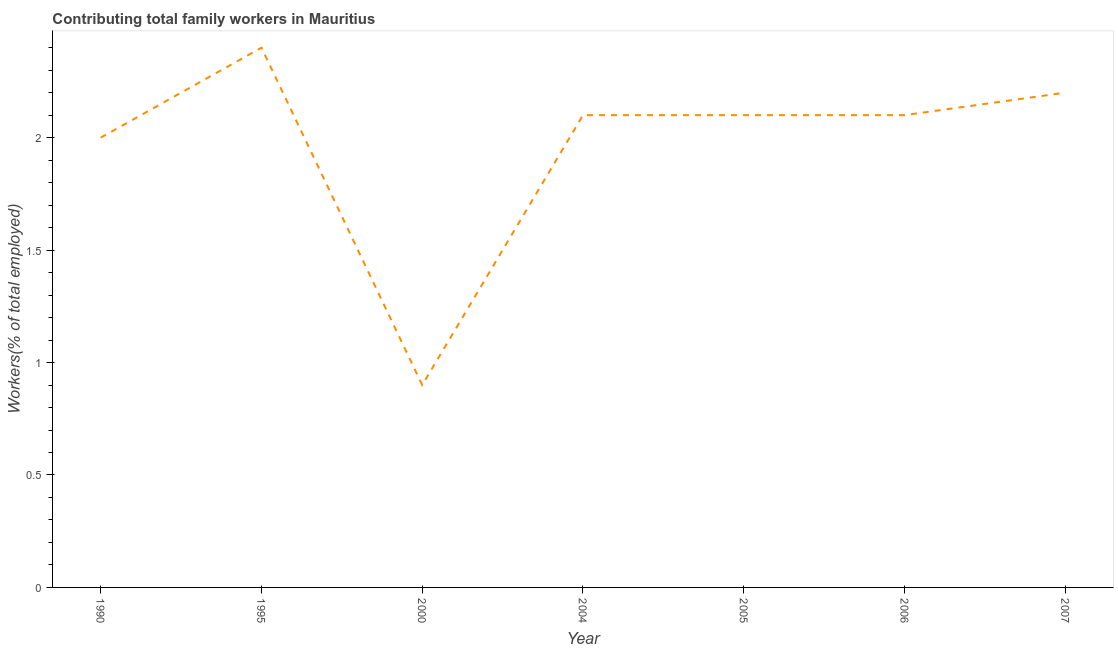What is the contributing family workers in 1995?
Give a very brief answer. 2.4. Across all years, what is the maximum contributing family workers?
Keep it short and to the point. 2.4. Across all years, what is the minimum contributing family workers?
Offer a very short reply. 0.9. What is the sum of the contributing family workers?
Ensure brevity in your answer.  13.8. What is the difference between the contributing family workers in 1995 and 2000?
Provide a succinct answer. 1.5. What is the average contributing family workers per year?
Your answer should be very brief. 1.97. What is the median contributing family workers?
Give a very brief answer. 2.1. In how many years, is the contributing family workers greater than 1.4 %?
Give a very brief answer. 6. What is the ratio of the contributing family workers in 1995 to that in 2000?
Your response must be concise. 2.67. Is the contributing family workers in 2004 less than that in 2006?
Provide a succinct answer. No. Is the difference between the contributing family workers in 1995 and 2006 greater than the difference between any two years?
Your answer should be very brief. No. What is the difference between the highest and the second highest contributing family workers?
Provide a short and direct response. 0.2. What is the difference between the highest and the lowest contributing family workers?
Your response must be concise. 1.5. Does the contributing family workers monotonically increase over the years?
Provide a succinct answer. No. How many lines are there?
Provide a short and direct response. 1. How many years are there in the graph?
Provide a succinct answer. 7. Are the values on the major ticks of Y-axis written in scientific E-notation?
Make the answer very short. No. Does the graph contain grids?
Provide a succinct answer. No. What is the title of the graph?
Make the answer very short. Contributing total family workers in Mauritius. What is the label or title of the Y-axis?
Keep it short and to the point. Workers(% of total employed). What is the Workers(% of total employed) of 1990?
Your response must be concise. 2. What is the Workers(% of total employed) of 1995?
Ensure brevity in your answer.  2.4. What is the Workers(% of total employed) in 2000?
Give a very brief answer. 0.9. What is the Workers(% of total employed) of 2004?
Give a very brief answer. 2.1. What is the Workers(% of total employed) in 2005?
Keep it short and to the point. 2.1. What is the Workers(% of total employed) of 2006?
Your answer should be compact. 2.1. What is the Workers(% of total employed) of 2007?
Ensure brevity in your answer.  2.2. What is the difference between the Workers(% of total employed) in 1990 and 2000?
Offer a very short reply. 1.1. What is the difference between the Workers(% of total employed) in 1990 and 2005?
Offer a very short reply. -0.1. What is the difference between the Workers(% of total employed) in 1990 and 2007?
Keep it short and to the point. -0.2. What is the difference between the Workers(% of total employed) in 1995 and 2004?
Offer a terse response. 0.3. What is the difference between the Workers(% of total employed) in 1995 and 2005?
Make the answer very short. 0.3. What is the difference between the Workers(% of total employed) in 1995 and 2006?
Give a very brief answer. 0.3. What is the difference between the Workers(% of total employed) in 1995 and 2007?
Keep it short and to the point. 0.2. What is the difference between the Workers(% of total employed) in 2000 and 2005?
Ensure brevity in your answer.  -1.2. What is the difference between the Workers(% of total employed) in 2000 and 2006?
Provide a short and direct response. -1.2. What is the difference between the Workers(% of total employed) in 2000 and 2007?
Offer a very short reply. -1.3. What is the difference between the Workers(% of total employed) in 2004 and 2005?
Ensure brevity in your answer.  0. What is the difference between the Workers(% of total employed) in 2004 and 2006?
Provide a short and direct response. 0. What is the difference between the Workers(% of total employed) in 2005 and 2006?
Offer a terse response. 0. What is the difference between the Workers(% of total employed) in 2006 and 2007?
Your response must be concise. -0.1. What is the ratio of the Workers(% of total employed) in 1990 to that in 1995?
Make the answer very short. 0.83. What is the ratio of the Workers(% of total employed) in 1990 to that in 2000?
Ensure brevity in your answer.  2.22. What is the ratio of the Workers(% of total employed) in 1990 to that in 2004?
Ensure brevity in your answer.  0.95. What is the ratio of the Workers(% of total employed) in 1990 to that in 2005?
Your answer should be compact. 0.95. What is the ratio of the Workers(% of total employed) in 1990 to that in 2007?
Provide a short and direct response. 0.91. What is the ratio of the Workers(% of total employed) in 1995 to that in 2000?
Make the answer very short. 2.67. What is the ratio of the Workers(% of total employed) in 1995 to that in 2004?
Your response must be concise. 1.14. What is the ratio of the Workers(% of total employed) in 1995 to that in 2005?
Provide a succinct answer. 1.14. What is the ratio of the Workers(% of total employed) in 1995 to that in 2006?
Offer a very short reply. 1.14. What is the ratio of the Workers(% of total employed) in 1995 to that in 2007?
Your response must be concise. 1.09. What is the ratio of the Workers(% of total employed) in 2000 to that in 2004?
Your answer should be compact. 0.43. What is the ratio of the Workers(% of total employed) in 2000 to that in 2005?
Make the answer very short. 0.43. What is the ratio of the Workers(% of total employed) in 2000 to that in 2006?
Provide a succinct answer. 0.43. What is the ratio of the Workers(% of total employed) in 2000 to that in 2007?
Offer a very short reply. 0.41. What is the ratio of the Workers(% of total employed) in 2004 to that in 2006?
Keep it short and to the point. 1. What is the ratio of the Workers(% of total employed) in 2004 to that in 2007?
Provide a short and direct response. 0.95. What is the ratio of the Workers(% of total employed) in 2005 to that in 2006?
Provide a succinct answer. 1. What is the ratio of the Workers(% of total employed) in 2005 to that in 2007?
Your answer should be very brief. 0.95. What is the ratio of the Workers(% of total employed) in 2006 to that in 2007?
Ensure brevity in your answer.  0.95. 